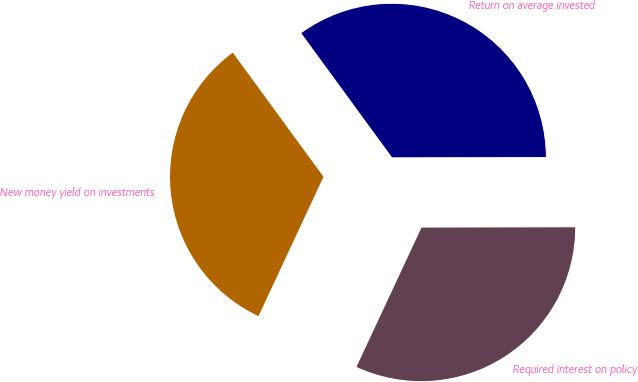Convert chart to OTSL. <chart><loc_0><loc_0><loc_500><loc_500><pie_chart><fcel>New money yield on investments<fcel>Required interest on policy<fcel>Return on average invested<nl><fcel>33.01%<fcel>31.98%<fcel>35.02%<nl></chart> 